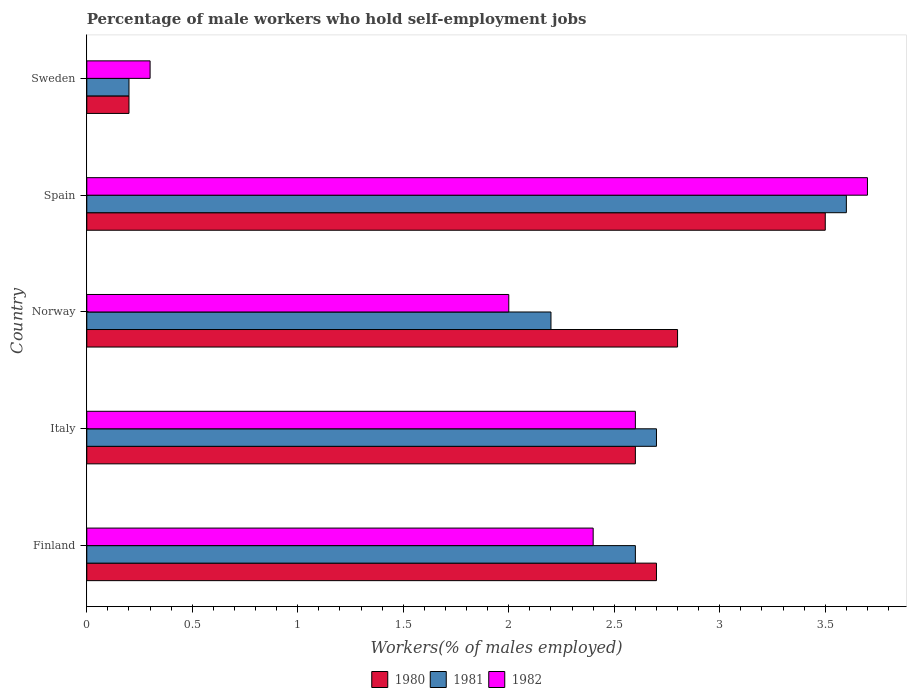Are the number of bars per tick equal to the number of legend labels?
Keep it short and to the point. Yes. Are the number of bars on each tick of the Y-axis equal?
Make the answer very short. Yes. What is the percentage of self-employed male workers in 1980 in Finland?
Give a very brief answer. 2.7. Across all countries, what is the maximum percentage of self-employed male workers in 1982?
Ensure brevity in your answer.  3.7. Across all countries, what is the minimum percentage of self-employed male workers in 1980?
Your answer should be very brief. 0.2. What is the total percentage of self-employed male workers in 1980 in the graph?
Ensure brevity in your answer.  11.8. What is the difference between the percentage of self-employed male workers in 1981 in Finland and that in Italy?
Your answer should be very brief. -0.1. What is the difference between the percentage of self-employed male workers in 1980 in Italy and the percentage of self-employed male workers in 1982 in Spain?
Your answer should be compact. -1.1. What is the average percentage of self-employed male workers in 1981 per country?
Keep it short and to the point. 2.26. What is the difference between the percentage of self-employed male workers in 1980 and percentage of self-employed male workers in 1981 in Norway?
Your response must be concise. 0.6. What is the ratio of the percentage of self-employed male workers in 1980 in Italy to that in Norway?
Keep it short and to the point. 0.93. Is the percentage of self-employed male workers in 1982 in Finland less than that in Norway?
Provide a succinct answer. No. What is the difference between the highest and the second highest percentage of self-employed male workers in 1982?
Your answer should be very brief. 1.1. What is the difference between the highest and the lowest percentage of self-employed male workers in 1980?
Your answer should be very brief. 3.3. In how many countries, is the percentage of self-employed male workers in 1982 greater than the average percentage of self-employed male workers in 1982 taken over all countries?
Offer a very short reply. 3. What does the 3rd bar from the top in Norway represents?
Offer a very short reply. 1980. How many bars are there?
Your answer should be very brief. 15. How many countries are there in the graph?
Your answer should be compact. 5. What is the difference between two consecutive major ticks on the X-axis?
Provide a short and direct response. 0.5. Are the values on the major ticks of X-axis written in scientific E-notation?
Your answer should be compact. No. Does the graph contain grids?
Make the answer very short. No. Where does the legend appear in the graph?
Offer a terse response. Bottom center. How many legend labels are there?
Offer a very short reply. 3. How are the legend labels stacked?
Your answer should be compact. Horizontal. What is the title of the graph?
Provide a succinct answer. Percentage of male workers who hold self-employment jobs. What is the label or title of the X-axis?
Offer a terse response. Workers(% of males employed). What is the Workers(% of males employed) of 1980 in Finland?
Your answer should be very brief. 2.7. What is the Workers(% of males employed) of 1981 in Finland?
Provide a short and direct response. 2.6. What is the Workers(% of males employed) in 1982 in Finland?
Your response must be concise. 2.4. What is the Workers(% of males employed) of 1980 in Italy?
Provide a succinct answer. 2.6. What is the Workers(% of males employed) in 1981 in Italy?
Offer a very short reply. 2.7. What is the Workers(% of males employed) in 1982 in Italy?
Your answer should be compact. 2.6. What is the Workers(% of males employed) of 1980 in Norway?
Provide a succinct answer. 2.8. What is the Workers(% of males employed) in 1981 in Norway?
Offer a terse response. 2.2. What is the Workers(% of males employed) in 1982 in Norway?
Your answer should be very brief. 2. What is the Workers(% of males employed) of 1980 in Spain?
Your answer should be very brief. 3.5. What is the Workers(% of males employed) of 1981 in Spain?
Your answer should be compact. 3.6. What is the Workers(% of males employed) in 1982 in Spain?
Your answer should be very brief. 3.7. What is the Workers(% of males employed) in 1980 in Sweden?
Provide a short and direct response. 0.2. What is the Workers(% of males employed) in 1981 in Sweden?
Ensure brevity in your answer.  0.2. What is the Workers(% of males employed) in 1982 in Sweden?
Ensure brevity in your answer.  0.3. Across all countries, what is the maximum Workers(% of males employed) in 1981?
Your response must be concise. 3.6. Across all countries, what is the maximum Workers(% of males employed) in 1982?
Provide a short and direct response. 3.7. Across all countries, what is the minimum Workers(% of males employed) in 1980?
Ensure brevity in your answer.  0.2. Across all countries, what is the minimum Workers(% of males employed) in 1981?
Provide a short and direct response. 0.2. Across all countries, what is the minimum Workers(% of males employed) of 1982?
Make the answer very short. 0.3. What is the total Workers(% of males employed) in 1980 in the graph?
Provide a succinct answer. 11.8. What is the difference between the Workers(% of males employed) in 1980 in Finland and that in Italy?
Provide a succinct answer. 0.1. What is the difference between the Workers(% of males employed) of 1981 in Finland and that in Italy?
Keep it short and to the point. -0.1. What is the difference between the Workers(% of males employed) in 1982 in Finland and that in Italy?
Make the answer very short. -0.2. What is the difference between the Workers(% of males employed) in 1982 in Finland and that in Norway?
Your response must be concise. 0.4. What is the difference between the Workers(% of males employed) of 1980 in Finland and that in Spain?
Make the answer very short. -0.8. What is the difference between the Workers(% of males employed) in 1980 in Finland and that in Sweden?
Your response must be concise. 2.5. What is the difference between the Workers(% of males employed) of 1982 in Finland and that in Sweden?
Provide a short and direct response. 2.1. What is the difference between the Workers(% of males employed) of 1980 in Italy and that in Norway?
Your answer should be compact. -0.2. What is the difference between the Workers(% of males employed) in 1980 in Italy and that in Spain?
Provide a succinct answer. -0.9. What is the difference between the Workers(% of males employed) in 1981 in Italy and that in Spain?
Provide a succinct answer. -0.9. What is the difference between the Workers(% of males employed) in 1982 in Italy and that in Spain?
Offer a very short reply. -1.1. What is the difference between the Workers(% of males employed) in 1981 in Italy and that in Sweden?
Offer a very short reply. 2.5. What is the difference between the Workers(% of males employed) of 1982 in Italy and that in Sweden?
Provide a short and direct response. 2.3. What is the difference between the Workers(% of males employed) in 1981 in Norway and that in Spain?
Ensure brevity in your answer.  -1.4. What is the difference between the Workers(% of males employed) in 1982 in Norway and that in Spain?
Keep it short and to the point. -1.7. What is the difference between the Workers(% of males employed) of 1980 in Spain and that in Sweden?
Your answer should be very brief. 3.3. What is the difference between the Workers(% of males employed) in 1980 in Finland and the Workers(% of males employed) in 1982 in Italy?
Keep it short and to the point. 0.1. What is the difference between the Workers(% of males employed) in 1980 in Finland and the Workers(% of males employed) in 1982 in Norway?
Ensure brevity in your answer.  0.7. What is the difference between the Workers(% of males employed) in 1981 in Finland and the Workers(% of males employed) in 1982 in Norway?
Provide a short and direct response. 0.6. What is the difference between the Workers(% of males employed) in 1980 in Finland and the Workers(% of males employed) in 1981 in Spain?
Ensure brevity in your answer.  -0.9. What is the difference between the Workers(% of males employed) of 1980 in Finland and the Workers(% of males employed) of 1982 in Spain?
Give a very brief answer. -1. What is the difference between the Workers(% of males employed) of 1980 in Finland and the Workers(% of males employed) of 1981 in Sweden?
Make the answer very short. 2.5. What is the difference between the Workers(% of males employed) of 1980 in Finland and the Workers(% of males employed) of 1982 in Sweden?
Provide a short and direct response. 2.4. What is the difference between the Workers(% of males employed) of 1981 in Finland and the Workers(% of males employed) of 1982 in Sweden?
Your response must be concise. 2.3. What is the difference between the Workers(% of males employed) of 1980 in Italy and the Workers(% of males employed) of 1982 in Norway?
Provide a succinct answer. 0.6. What is the difference between the Workers(% of males employed) of 1980 in Italy and the Workers(% of males employed) of 1981 in Sweden?
Your answer should be very brief. 2.4. What is the difference between the Workers(% of males employed) in 1980 in Italy and the Workers(% of males employed) in 1982 in Sweden?
Provide a succinct answer. 2.3. What is the difference between the Workers(% of males employed) in 1981 in Italy and the Workers(% of males employed) in 1982 in Sweden?
Your response must be concise. 2.4. What is the difference between the Workers(% of males employed) in 1980 in Norway and the Workers(% of males employed) in 1981 in Spain?
Offer a terse response. -0.8. What is the difference between the Workers(% of males employed) in 1980 in Norway and the Workers(% of males employed) in 1982 in Spain?
Your response must be concise. -0.9. What is the difference between the Workers(% of males employed) in 1980 in Norway and the Workers(% of males employed) in 1981 in Sweden?
Your answer should be very brief. 2.6. What is the difference between the Workers(% of males employed) in 1981 in Norway and the Workers(% of males employed) in 1982 in Sweden?
Give a very brief answer. 1.9. What is the difference between the Workers(% of males employed) of 1980 in Spain and the Workers(% of males employed) of 1981 in Sweden?
Provide a succinct answer. 3.3. What is the difference between the Workers(% of males employed) of 1980 in Spain and the Workers(% of males employed) of 1982 in Sweden?
Your answer should be very brief. 3.2. What is the difference between the Workers(% of males employed) in 1981 in Spain and the Workers(% of males employed) in 1982 in Sweden?
Your response must be concise. 3.3. What is the average Workers(% of males employed) in 1980 per country?
Give a very brief answer. 2.36. What is the average Workers(% of males employed) in 1981 per country?
Keep it short and to the point. 2.26. What is the difference between the Workers(% of males employed) in 1980 and Workers(% of males employed) in 1982 in Finland?
Make the answer very short. 0.3. What is the difference between the Workers(% of males employed) of 1980 and Workers(% of males employed) of 1981 in Norway?
Ensure brevity in your answer.  0.6. What is the difference between the Workers(% of males employed) of 1980 and Workers(% of males employed) of 1982 in Norway?
Ensure brevity in your answer.  0.8. What is the difference between the Workers(% of males employed) of 1981 and Workers(% of males employed) of 1982 in Norway?
Provide a short and direct response. 0.2. What is the difference between the Workers(% of males employed) in 1980 and Workers(% of males employed) in 1982 in Spain?
Keep it short and to the point. -0.2. What is the difference between the Workers(% of males employed) in 1980 and Workers(% of males employed) in 1981 in Sweden?
Offer a terse response. 0. What is the difference between the Workers(% of males employed) of 1980 and Workers(% of males employed) of 1982 in Sweden?
Make the answer very short. -0.1. What is the difference between the Workers(% of males employed) of 1981 and Workers(% of males employed) of 1982 in Sweden?
Make the answer very short. -0.1. What is the ratio of the Workers(% of males employed) in 1980 in Finland to that in Italy?
Your response must be concise. 1.04. What is the ratio of the Workers(% of males employed) of 1981 in Finland to that in Norway?
Keep it short and to the point. 1.18. What is the ratio of the Workers(% of males employed) of 1980 in Finland to that in Spain?
Your answer should be very brief. 0.77. What is the ratio of the Workers(% of males employed) in 1981 in Finland to that in Spain?
Make the answer very short. 0.72. What is the ratio of the Workers(% of males employed) in 1982 in Finland to that in Spain?
Your answer should be very brief. 0.65. What is the ratio of the Workers(% of males employed) of 1982 in Finland to that in Sweden?
Your answer should be compact. 8. What is the ratio of the Workers(% of males employed) of 1981 in Italy to that in Norway?
Your response must be concise. 1.23. What is the ratio of the Workers(% of males employed) of 1980 in Italy to that in Spain?
Offer a very short reply. 0.74. What is the ratio of the Workers(% of males employed) of 1982 in Italy to that in Spain?
Offer a terse response. 0.7. What is the ratio of the Workers(% of males employed) in 1982 in Italy to that in Sweden?
Offer a very short reply. 8.67. What is the ratio of the Workers(% of males employed) in 1981 in Norway to that in Spain?
Your answer should be very brief. 0.61. What is the ratio of the Workers(% of males employed) of 1982 in Norway to that in Spain?
Provide a succinct answer. 0.54. What is the ratio of the Workers(% of males employed) of 1982 in Norway to that in Sweden?
Provide a succinct answer. 6.67. What is the ratio of the Workers(% of males employed) of 1980 in Spain to that in Sweden?
Your response must be concise. 17.5. What is the ratio of the Workers(% of males employed) in 1982 in Spain to that in Sweden?
Your response must be concise. 12.33. What is the difference between the highest and the second highest Workers(% of males employed) of 1981?
Offer a terse response. 0.9. What is the difference between the highest and the lowest Workers(% of males employed) of 1980?
Give a very brief answer. 3.3. What is the difference between the highest and the lowest Workers(% of males employed) of 1982?
Your answer should be very brief. 3.4. 